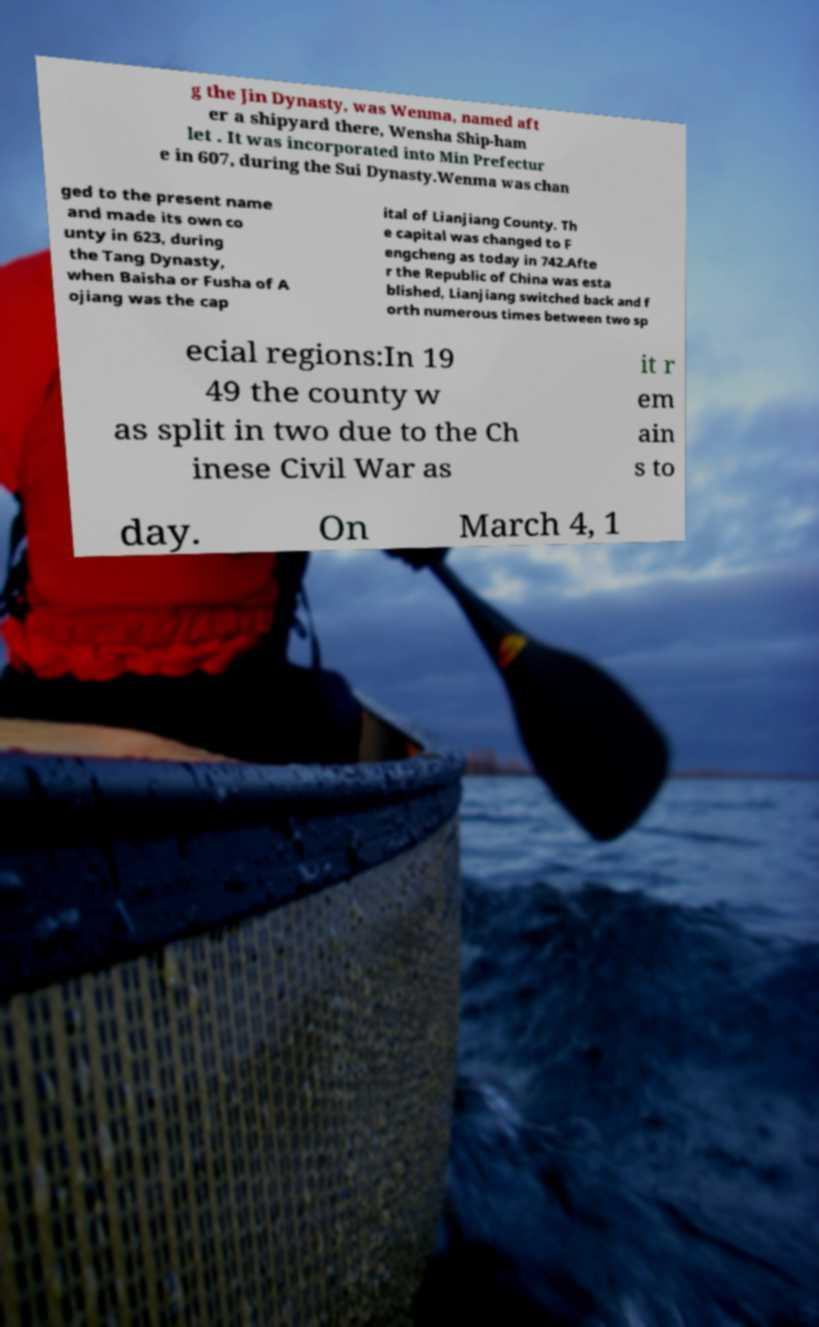Can you accurately transcribe the text from the provided image for me? g the Jin Dynasty, was Wenma, named aft er a shipyard there, Wensha Ship-ham let . It was incorporated into Min Prefectur e in 607, during the Sui Dynasty.Wenma was chan ged to the present name and made its own co unty in 623, during the Tang Dynasty, when Baisha or Fusha of A ojiang was the cap ital of Lianjiang County. Th e capital was changed to F engcheng as today in 742.Afte r the Republic of China was esta blished, Lianjiang switched back and f orth numerous times between two sp ecial regions:In 19 49 the county w as split in two due to the Ch inese Civil War as it r em ain s to day. On March 4, 1 